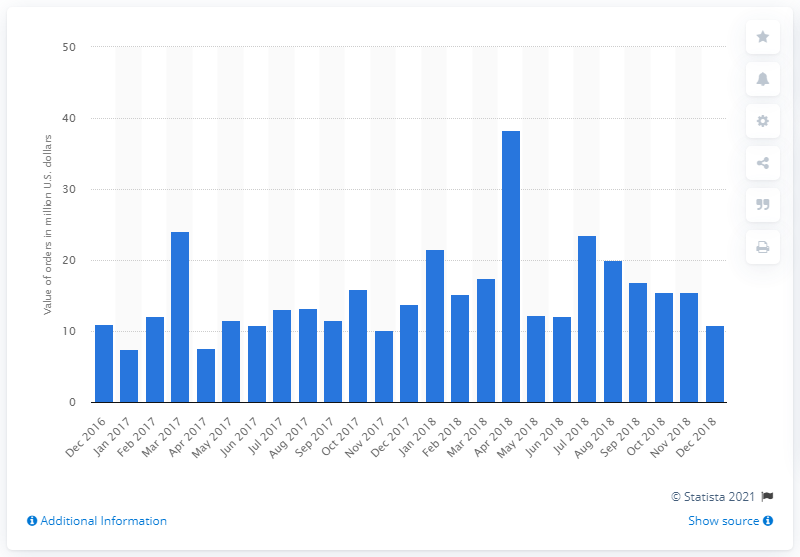Highlight a few significant elements in this photo. In December 2018, the total value of all orders for metal forming and fabricating machines for domestic consumption was 10.82 million dollars. 